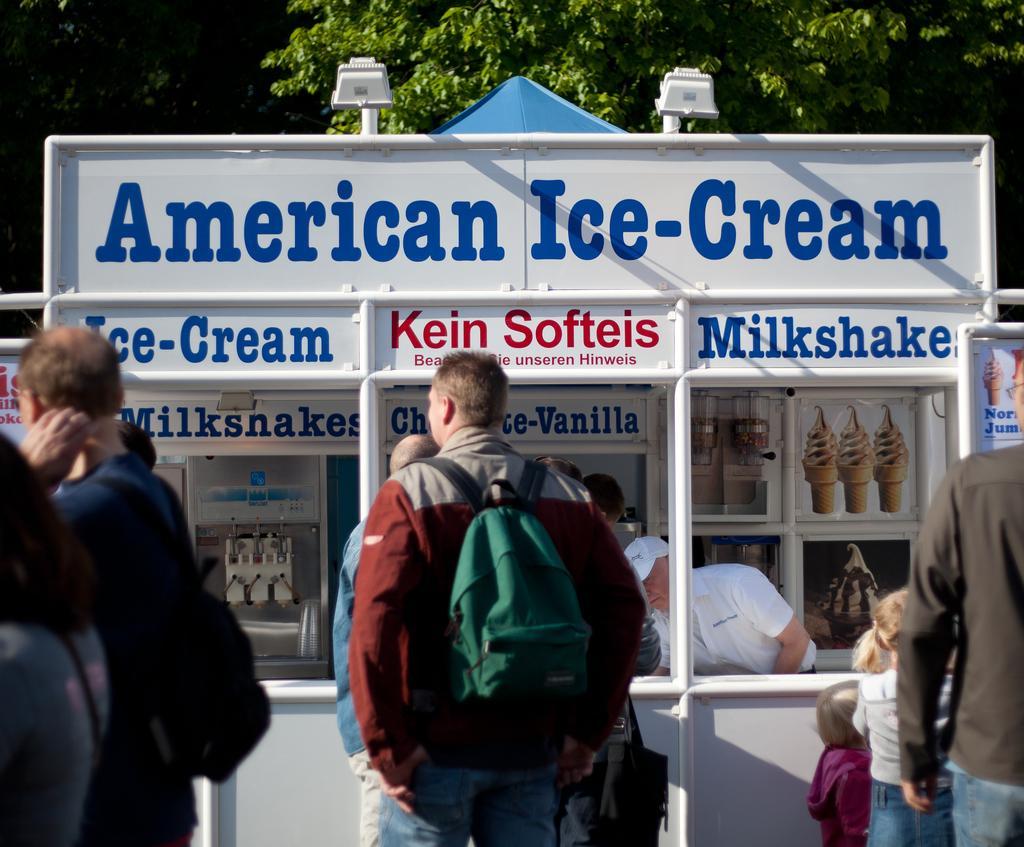In one or two sentences, can you explain what this image depicts? In this picture I can see the ice cream stall. I can see a person carrying the bag. I can see the lights. 